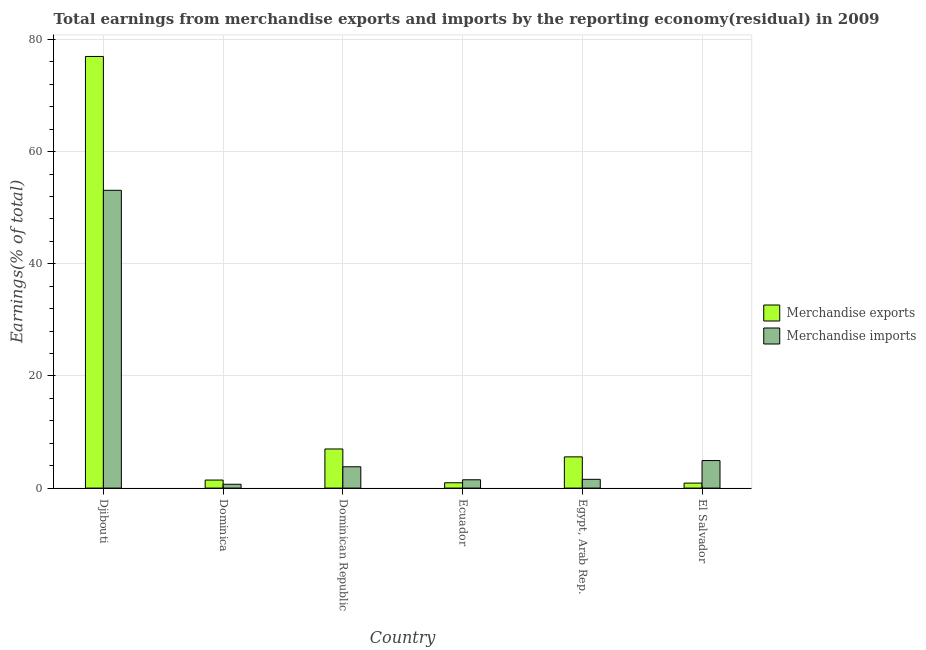How many different coloured bars are there?
Make the answer very short. 2. How many groups of bars are there?
Provide a short and direct response. 6. How many bars are there on the 6th tick from the left?
Keep it short and to the point. 2. What is the label of the 1st group of bars from the left?
Ensure brevity in your answer.  Djibouti. In how many cases, is the number of bars for a given country not equal to the number of legend labels?
Your answer should be compact. 0. What is the earnings from merchandise imports in El Salvador?
Offer a terse response. 4.91. Across all countries, what is the maximum earnings from merchandise imports?
Your answer should be compact. 53.1. Across all countries, what is the minimum earnings from merchandise exports?
Your answer should be very brief. 0.89. In which country was the earnings from merchandise imports maximum?
Provide a short and direct response. Djibouti. In which country was the earnings from merchandise exports minimum?
Provide a short and direct response. El Salvador. What is the total earnings from merchandise imports in the graph?
Make the answer very short. 65.54. What is the difference between the earnings from merchandise exports in Dominica and that in Ecuador?
Give a very brief answer. 0.48. What is the difference between the earnings from merchandise imports in Djibouti and the earnings from merchandise exports in El Salvador?
Give a very brief answer. 52.21. What is the average earnings from merchandise imports per country?
Your answer should be compact. 10.92. What is the difference between the earnings from merchandise imports and earnings from merchandise exports in Dominica?
Your response must be concise. -0.75. In how many countries, is the earnings from merchandise exports greater than 64 %?
Offer a very short reply. 1. What is the ratio of the earnings from merchandise exports in Djibouti to that in Egypt, Arab Rep.?
Your answer should be compact. 13.83. Is the earnings from merchandise imports in Dominica less than that in El Salvador?
Your answer should be compact. Yes. Is the difference between the earnings from merchandise exports in Ecuador and Egypt, Arab Rep. greater than the difference between the earnings from merchandise imports in Ecuador and Egypt, Arab Rep.?
Provide a short and direct response. No. What is the difference between the highest and the second highest earnings from merchandise imports?
Your answer should be very brief. 48.19. What is the difference between the highest and the lowest earnings from merchandise exports?
Your answer should be compact. 76.08. In how many countries, is the earnings from merchandise imports greater than the average earnings from merchandise imports taken over all countries?
Your answer should be compact. 1. Are all the bars in the graph horizontal?
Give a very brief answer. No. How many countries are there in the graph?
Your answer should be compact. 6. Are the values on the major ticks of Y-axis written in scientific E-notation?
Provide a short and direct response. No. Does the graph contain any zero values?
Provide a succinct answer. No. Does the graph contain grids?
Ensure brevity in your answer.  Yes. How many legend labels are there?
Offer a terse response. 2. What is the title of the graph?
Provide a succinct answer. Total earnings from merchandise exports and imports by the reporting economy(residual) in 2009. Does "Female labourers" appear as one of the legend labels in the graph?
Your answer should be compact. No. What is the label or title of the X-axis?
Ensure brevity in your answer.  Country. What is the label or title of the Y-axis?
Provide a short and direct response. Earnings(% of total). What is the Earnings(% of total) in Merchandise exports in Djibouti?
Provide a succinct answer. 76.97. What is the Earnings(% of total) of Merchandise imports in Djibouti?
Your answer should be compact. 53.1. What is the Earnings(% of total) of Merchandise exports in Dominica?
Ensure brevity in your answer.  1.43. What is the Earnings(% of total) in Merchandise imports in Dominica?
Make the answer very short. 0.68. What is the Earnings(% of total) of Merchandise exports in Dominican Republic?
Make the answer very short. 6.97. What is the Earnings(% of total) of Merchandise imports in Dominican Republic?
Offer a very short reply. 3.8. What is the Earnings(% of total) of Merchandise exports in Ecuador?
Keep it short and to the point. 0.95. What is the Earnings(% of total) of Merchandise imports in Ecuador?
Make the answer very short. 1.48. What is the Earnings(% of total) of Merchandise exports in Egypt, Arab Rep.?
Your answer should be very brief. 5.57. What is the Earnings(% of total) in Merchandise imports in Egypt, Arab Rep.?
Make the answer very short. 1.56. What is the Earnings(% of total) of Merchandise exports in El Salvador?
Give a very brief answer. 0.89. What is the Earnings(% of total) in Merchandise imports in El Salvador?
Your answer should be compact. 4.91. Across all countries, what is the maximum Earnings(% of total) of Merchandise exports?
Provide a succinct answer. 76.97. Across all countries, what is the maximum Earnings(% of total) in Merchandise imports?
Provide a short and direct response. 53.1. Across all countries, what is the minimum Earnings(% of total) of Merchandise exports?
Your response must be concise. 0.89. Across all countries, what is the minimum Earnings(% of total) in Merchandise imports?
Make the answer very short. 0.68. What is the total Earnings(% of total) in Merchandise exports in the graph?
Give a very brief answer. 92.78. What is the total Earnings(% of total) of Merchandise imports in the graph?
Ensure brevity in your answer.  65.54. What is the difference between the Earnings(% of total) in Merchandise exports in Djibouti and that in Dominica?
Keep it short and to the point. 75.53. What is the difference between the Earnings(% of total) in Merchandise imports in Djibouti and that in Dominica?
Give a very brief answer. 52.42. What is the difference between the Earnings(% of total) in Merchandise exports in Djibouti and that in Dominican Republic?
Offer a terse response. 69.99. What is the difference between the Earnings(% of total) in Merchandise imports in Djibouti and that in Dominican Republic?
Offer a very short reply. 49.3. What is the difference between the Earnings(% of total) of Merchandise exports in Djibouti and that in Ecuador?
Your answer should be compact. 76.02. What is the difference between the Earnings(% of total) of Merchandise imports in Djibouti and that in Ecuador?
Your answer should be compact. 51.62. What is the difference between the Earnings(% of total) of Merchandise exports in Djibouti and that in Egypt, Arab Rep.?
Offer a very short reply. 71.4. What is the difference between the Earnings(% of total) in Merchandise imports in Djibouti and that in Egypt, Arab Rep.?
Provide a succinct answer. 51.54. What is the difference between the Earnings(% of total) of Merchandise exports in Djibouti and that in El Salvador?
Keep it short and to the point. 76.08. What is the difference between the Earnings(% of total) in Merchandise imports in Djibouti and that in El Salvador?
Ensure brevity in your answer.  48.19. What is the difference between the Earnings(% of total) in Merchandise exports in Dominica and that in Dominican Republic?
Your answer should be compact. -5.54. What is the difference between the Earnings(% of total) in Merchandise imports in Dominica and that in Dominican Republic?
Keep it short and to the point. -3.12. What is the difference between the Earnings(% of total) in Merchandise exports in Dominica and that in Ecuador?
Offer a very short reply. 0.48. What is the difference between the Earnings(% of total) of Merchandise imports in Dominica and that in Ecuador?
Provide a succinct answer. -0.8. What is the difference between the Earnings(% of total) of Merchandise exports in Dominica and that in Egypt, Arab Rep.?
Provide a succinct answer. -4.13. What is the difference between the Earnings(% of total) in Merchandise imports in Dominica and that in Egypt, Arab Rep.?
Make the answer very short. -0.88. What is the difference between the Earnings(% of total) of Merchandise exports in Dominica and that in El Salvador?
Provide a succinct answer. 0.54. What is the difference between the Earnings(% of total) of Merchandise imports in Dominica and that in El Salvador?
Your answer should be very brief. -4.23. What is the difference between the Earnings(% of total) of Merchandise exports in Dominican Republic and that in Ecuador?
Your answer should be very brief. 6.02. What is the difference between the Earnings(% of total) in Merchandise imports in Dominican Republic and that in Ecuador?
Provide a succinct answer. 2.32. What is the difference between the Earnings(% of total) of Merchandise exports in Dominican Republic and that in Egypt, Arab Rep.?
Give a very brief answer. 1.41. What is the difference between the Earnings(% of total) of Merchandise imports in Dominican Republic and that in Egypt, Arab Rep.?
Your answer should be compact. 2.24. What is the difference between the Earnings(% of total) of Merchandise exports in Dominican Republic and that in El Salvador?
Ensure brevity in your answer.  6.08. What is the difference between the Earnings(% of total) in Merchandise imports in Dominican Republic and that in El Salvador?
Offer a very short reply. -1.11. What is the difference between the Earnings(% of total) of Merchandise exports in Ecuador and that in Egypt, Arab Rep.?
Make the answer very short. -4.62. What is the difference between the Earnings(% of total) in Merchandise imports in Ecuador and that in Egypt, Arab Rep.?
Provide a short and direct response. -0.08. What is the difference between the Earnings(% of total) in Merchandise exports in Ecuador and that in El Salvador?
Your answer should be very brief. 0.06. What is the difference between the Earnings(% of total) in Merchandise imports in Ecuador and that in El Salvador?
Offer a very short reply. -3.43. What is the difference between the Earnings(% of total) in Merchandise exports in Egypt, Arab Rep. and that in El Salvador?
Your answer should be compact. 4.68. What is the difference between the Earnings(% of total) in Merchandise imports in Egypt, Arab Rep. and that in El Salvador?
Your answer should be very brief. -3.35. What is the difference between the Earnings(% of total) in Merchandise exports in Djibouti and the Earnings(% of total) in Merchandise imports in Dominica?
Your answer should be compact. 76.28. What is the difference between the Earnings(% of total) in Merchandise exports in Djibouti and the Earnings(% of total) in Merchandise imports in Dominican Republic?
Offer a very short reply. 73.17. What is the difference between the Earnings(% of total) of Merchandise exports in Djibouti and the Earnings(% of total) of Merchandise imports in Ecuador?
Your answer should be compact. 75.48. What is the difference between the Earnings(% of total) of Merchandise exports in Djibouti and the Earnings(% of total) of Merchandise imports in Egypt, Arab Rep.?
Ensure brevity in your answer.  75.4. What is the difference between the Earnings(% of total) of Merchandise exports in Djibouti and the Earnings(% of total) of Merchandise imports in El Salvador?
Make the answer very short. 72.05. What is the difference between the Earnings(% of total) in Merchandise exports in Dominica and the Earnings(% of total) in Merchandise imports in Dominican Republic?
Your answer should be very brief. -2.37. What is the difference between the Earnings(% of total) of Merchandise exports in Dominica and the Earnings(% of total) of Merchandise imports in Ecuador?
Your response must be concise. -0.05. What is the difference between the Earnings(% of total) of Merchandise exports in Dominica and the Earnings(% of total) of Merchandise imports in Egypt, Arab Rep.?
Your answer should be compact. -0.13. What is the difference between the Earnings(% of total) of Merchandise exports in Dominica and the Earnings(% of total) of Merchandise imports in El Salvador?
Ensure brevity in your answer.  -3.48. What is the difference between the Earnings(% of total) of Merchandise exports in Dominican Republic and the Earnings(% of total) of Merchandise imports in Ecuador?
Give a very brief answer. 5.49. What is the difference between the Earnings(% of total) in Merchandise exports in Dominican Republic and the Earnings(% of total) in Merchandise imports in Egypt, Arab Rep.?
Your response must be concise. 5.41. What is the difference between the Earnings(% of total) in Merchandise exports in Dominican Republic and the Earnings(% of total) in Merchandise imports in El Salvador?
Your answer should be very brief. 2.06. What is the difference between the Earnings(% of total) in Merchandise exports in Ecuador and the Earnings(% of total) in Merchandise imports in Egypt, Arab Rep.?
Keep it short and to the point. -0.61. What is the difference between the Earnings(% of total) in Merchandise exports in Ecuador and the Earnings(% of total) in Merchandise imports in El Salvador?
Ensure brevity in your answer.  -3.96. What is the difference between the Earnings(% of total) in Merchandise exports in Egypt, Arab Rep. and the Earnings(% of total) in Merchandise imports in El Salvador?
Your answer should be very brief. 0.66. What is the average Earnings(% of total) in Merchandise exports per country?
Make the answer very short. 15.46. What is the average Earnings(% of total) of Merchandise imports per country?
Give a very brief answer. 10.92. What is the difference between the Earnings(% of total) of Merchandise exports and Earnings(% of total) of Merchandise imports in Djibouti?
Your answer should be very brief. 23.87. What is the difference between the Earnings(% of total) in Merchandise exports and Earnings(% of total) in Merchandise imports in Dominica?
Your answer should be compact. 0.75. What is the difference between the Earnings(% of total) in Merchandise exports and Earnings(% of total) in Merchandise imports in Dominican Republic?
Your answer should be compact. 3.17. What is the difference between the Earnings(% of total) of Merchandise exports and Earnings(% of total) of Merchandise imports in Ecuador?
Your answer should be compact. -0.53. What is the difference between the Earnings(% of total) in Merchandise exports and Earnings(% of total) in Merchandise imports in Egypt, Arab Rep.?
Keep it short and to the point. 4. What is the difference between the Earnings(% of total) in Merchandise exports and Earnings(% of total) in Merchandise imports in El Salvador?
Offer a terse response. -4.02. What is the ratio of the Earnings(% of total) of Merchandise exports in Djibouti to that in Dominica?
Provide a succinct answer. 53.68. What is the ratio of the Earnings(% of total) in Merchandise imports in Djibouti to that in Dominica?
Keep it short and to the point. 77.54. What is the ratio of the Earnings(% of total) in Merchandise exports in Djibouti to that in Dominican Republic?
Ensure brevity in your answer.  11.04. What is the ratio of the Earnings(% of total) in Merchandise imports in Djibouti to that in Dominican Republic?
Ensure brevity in your answer.  13.97. What is the ratio of the Earnings(% of total) in Merchandise exports in Djibouti to that in Ecuador?
Offer a terse response. 81.11. What is the ratio of the Earnings(% of total) of Merchandise imports in Djibouti to that in Ecuador?
Provide a succinct answer. 35.8. What is the ratio of the Earnings(% of total) of Merchandise exports in Djibouti to that in Egypt, Arab Rep.?
Your answer should be compact. 13.83. What is the ratio of the Earnings(% of total) of Merchandise imports in Djibouti to that in Egypt, Arab Rep.?
Your answer should be very brief. 33.98. What is the ratio of the Earnings(% of total) of Merchandise exports in Djibouti to that in El Salvador?
Keep it short and to the point. 86.47. What is the ratio of the Earnings(% of total) in Merchandise imports in Djibouti to that in El Salvador?
Make the answer very short. 10.81. What is the ratio of the Earnings(% of total) of Merchandise exports in Dominica to that in Dominican Republic?
Offer a terse response. 0.21. What is the ratio of the Earnings(% of total) in Merchandise imports in Dominica to that in Dominican Republic?
Your response must be concise. 0.18. What is the ratio of the Earnings(% of total) in Merchandise exports in Dominica to that in Ecuador?
Offer a terse response. 1.51. What is the ratio of the Earnings(% of total) in Merchandise imports in Dominica to that in Ecuador?
Offer a terse response. 0.46. What is the ratio of the Earnings(% of total) in Merchandise exports in Dominica to that in Egypt, Arab Rep.?
Make the answer very short. 0.26. What is the ratio of the Earnings(% of total) of Merchandise imports in Dominica to that in Egypt, Arab Rep.?
Keep it short and to the point. 0.44. What is the ratio of the Earnings(% of total) in Merchandise exports in Dominica to that in El Salvador?
Provide a succinct answer. 1.61. What is the ratio of the Earnings(% of total) in Merchandise imports in Dominica to that in El Salvador?
Your response must be concise. 0.14. What is the ratio of the Earnings(% of total) in Merchandise exports in Dominican Republic to that in Ecuador?
Your response must be concise. 7.35. What is the ratio of the Earnings(% of total) of Merchandise imports in Dominican Republic to that in Ecuador?
Offer a terse response. 2.56. What is the ratio of the Earnings(% of total) of Merchandise exports in Dominican Republic to that in Egypt, Arab Rep.?
Keep it short and to the point. 1.25. What is the ratio of the Earnings(% of total) of Merchandise imports in Dominican Republic to that in Egypt, Arab Rep.?
Offer a very short reply. 2.43. What is the ratio of the Earnings(% of total) of Merchandise exports in Dominican Republic to that in El Salvador?
Offer a very short reply. 7.84. What is the ratio of the Earnings(% of total) of Merchandise imports in Dominican Republic to that in El Salvador?
Offer a very short reply. 0.77. What is the ratio of the Earnings(% of total) of Merchandise exports in Ecuador to that in Egypt, Arab Rep.?
Your answer should be compact. 0.17. What is the ratio of the Earnings(% of total) of Merchandise imports in Ecuador to that in Egypt, Arab Rep.?
Make the answer very short. 0.95. What is the ratio of the Earnings(% of total) in Merchandise exports in Ecuador to that in El Salvador?
Provide a succinct answer. 1.07. What is the ratio of the Earnings(% of total) in Merchandise imports in Ecuador to that in El Salvador?
Your answer should be compact. 0.3. What is the ratio of the Earnings(% of total) in Merchandise exports in Egypt, Arab Rep. to that in El Salvador?
Offer a terse response. 6.25. What is the ratio of the Earnings(% of total) in Merchandise imports in Egypt, Arab Rep. to that in El Salvador?
Give a very brief answer. 0.32. What is the difference between the highest and the second highest Earnings(% of total) of Merchandise exports?
Offer a very short reply. 69.99. What is the difference between the highest and the second highest Earnings(% of total) of Merchandise imports?
Your answer should be very brief. 48.19. What is the difference between the highest and the lowest Earnings(% of total) of Merchandise exports?
Your answer should be compact. 76.08. What is the difference between the highest and the lowest Earnings(% of total) of Merchandise imports?
Your response must be concise. 52.42. 